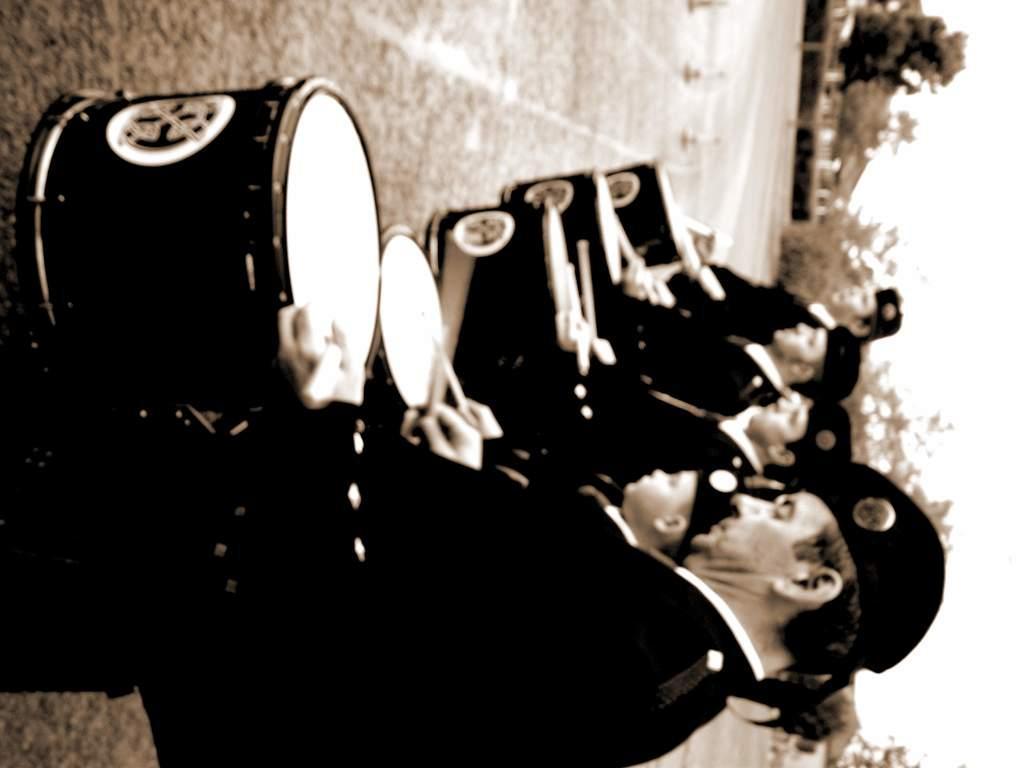Could you give a brief overview of what you see in this image? In this image I see few people who are holding drums and sticks and I see that all of them are wearing caps and I see the ground. In the background I see the trees and the sky. 